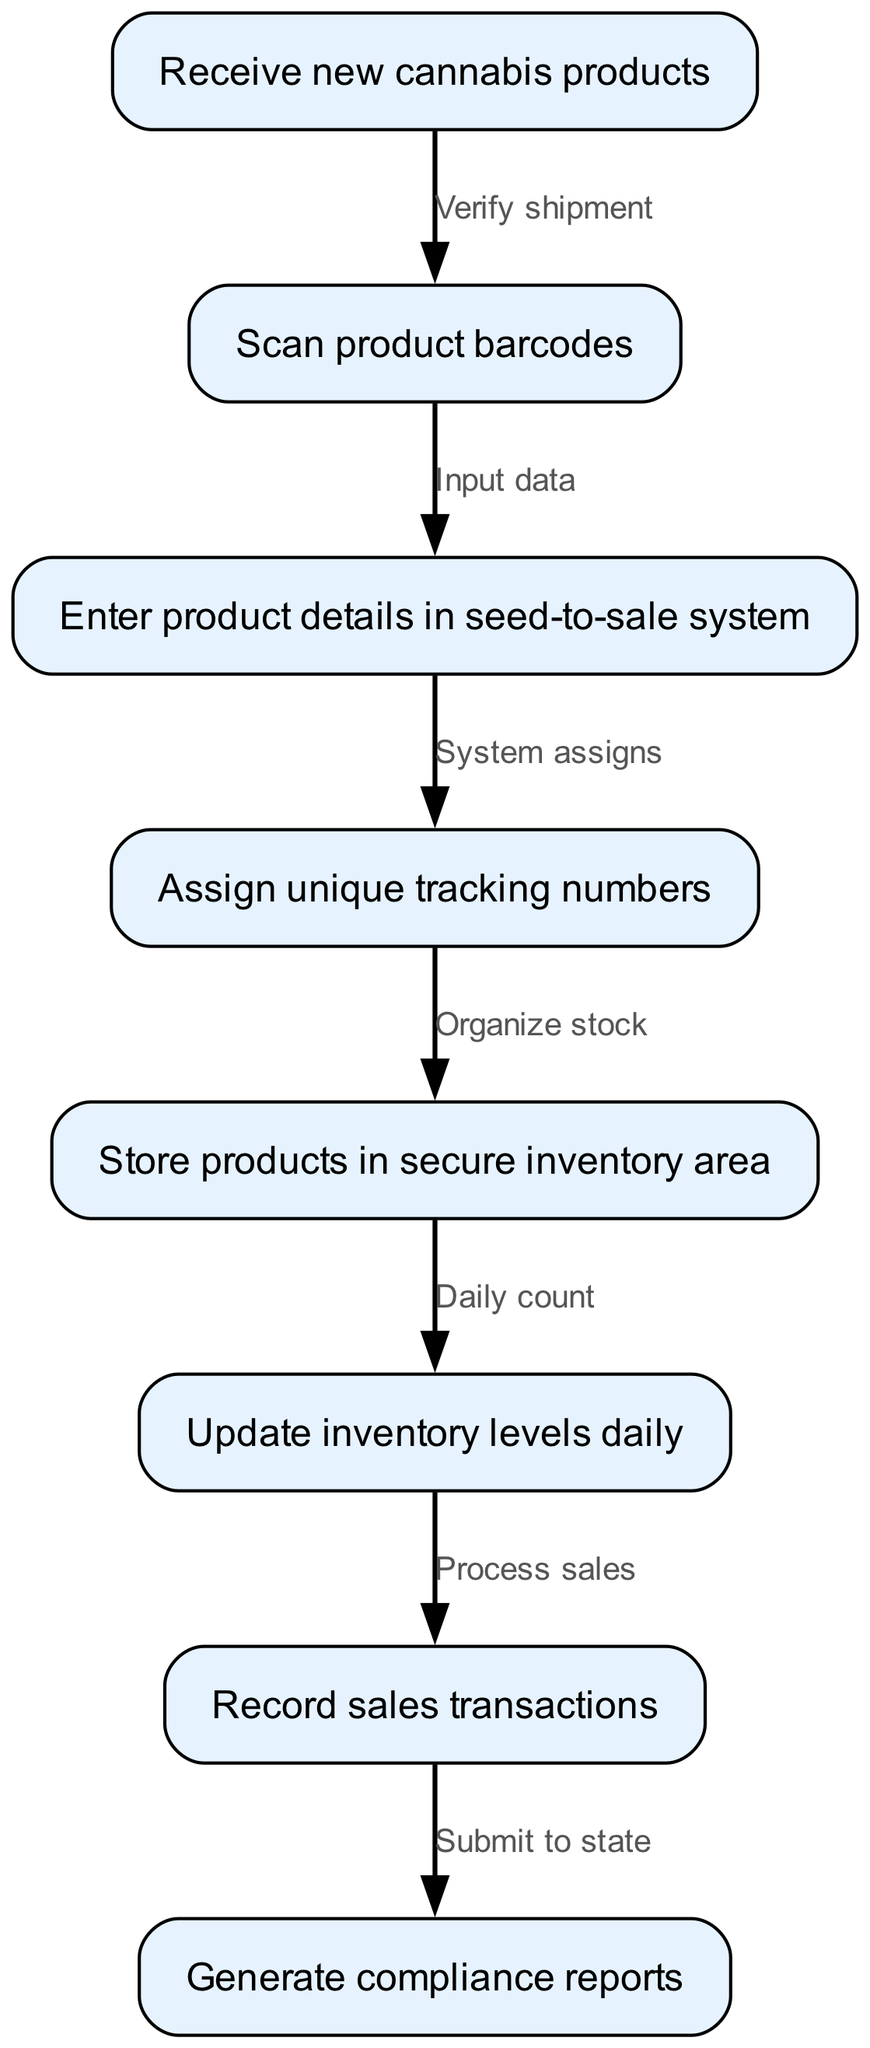How many nodes are in the workflow? By counting the individual actions or steps listed in the diagram, I see that there are eight distinct nodes: receiving products, scanning barcodes, entering details, assigning tracking numbers, storing products, updating inventory, recording transactions, and generating reports.
Answer: 8 What is the first action in the workflow? The first action in the diagram is clearly stated as "Receive new cannabis products". This is the starting point for the entire inventory management process.
Answer: Receive new cannabis products What action follows "Scan product barcodes"? Looking at the edges, the action that directly follows "Scan product barcodes" is "Enter product details in seed-to-sale system". The flow indicates a step-by-step progression from scanning to data entry.
Answer: Enter product details in seed-to-sale system What unique task is performed after "Assign unique tracking numbers"? After the action of assigning unique tracking numbers, the next step in the workflow is to "Store products in secure inventory area". This highlights the importance of organization following track assignment.
Answer: Store products in secure inventory area What is the relationship between "Record sales transactions" and "Generate compliance reports"? The edge connects "Record sales transactions" to "Generate compliance reports", indicating that sales activities are the precursor to reporting compliance, thus showcasing a dependence of the reporting process on the sales data.
Answer: Submit to state What is the last action in the workflow? The last action indicated in the diagram is "Generate compliance reports", showing that the workflow concludes with the necessity of reporting to the state. This signifies the importance of compliance in the inventory management process.
Answer: Generate compliance reports What process is initiated after the daily inventory levels are updated? Following the daily updates in inventory levels, the flow indicates that "Record sales transactions" is initiated. This shows the continuous cycle of inventory management in conjunction with sales activities.
Answer: Record sales transactions What key action is performed before storing products? According to the flow, the crucial action performed before storing products is "Assign unique tracking numbers". This step ensures that each product can be uniquely identified during storage and sales.
Answer: Assign unique tracking numbers What verifies the shipment before scanning product barcodes? The diagram clearly indicates that "Verify shipment" occurs before "Scan product barcodes". This step is essential for ensuring that received products match the order before progressing with inventory management tasks.
Answer: Verify shipment 